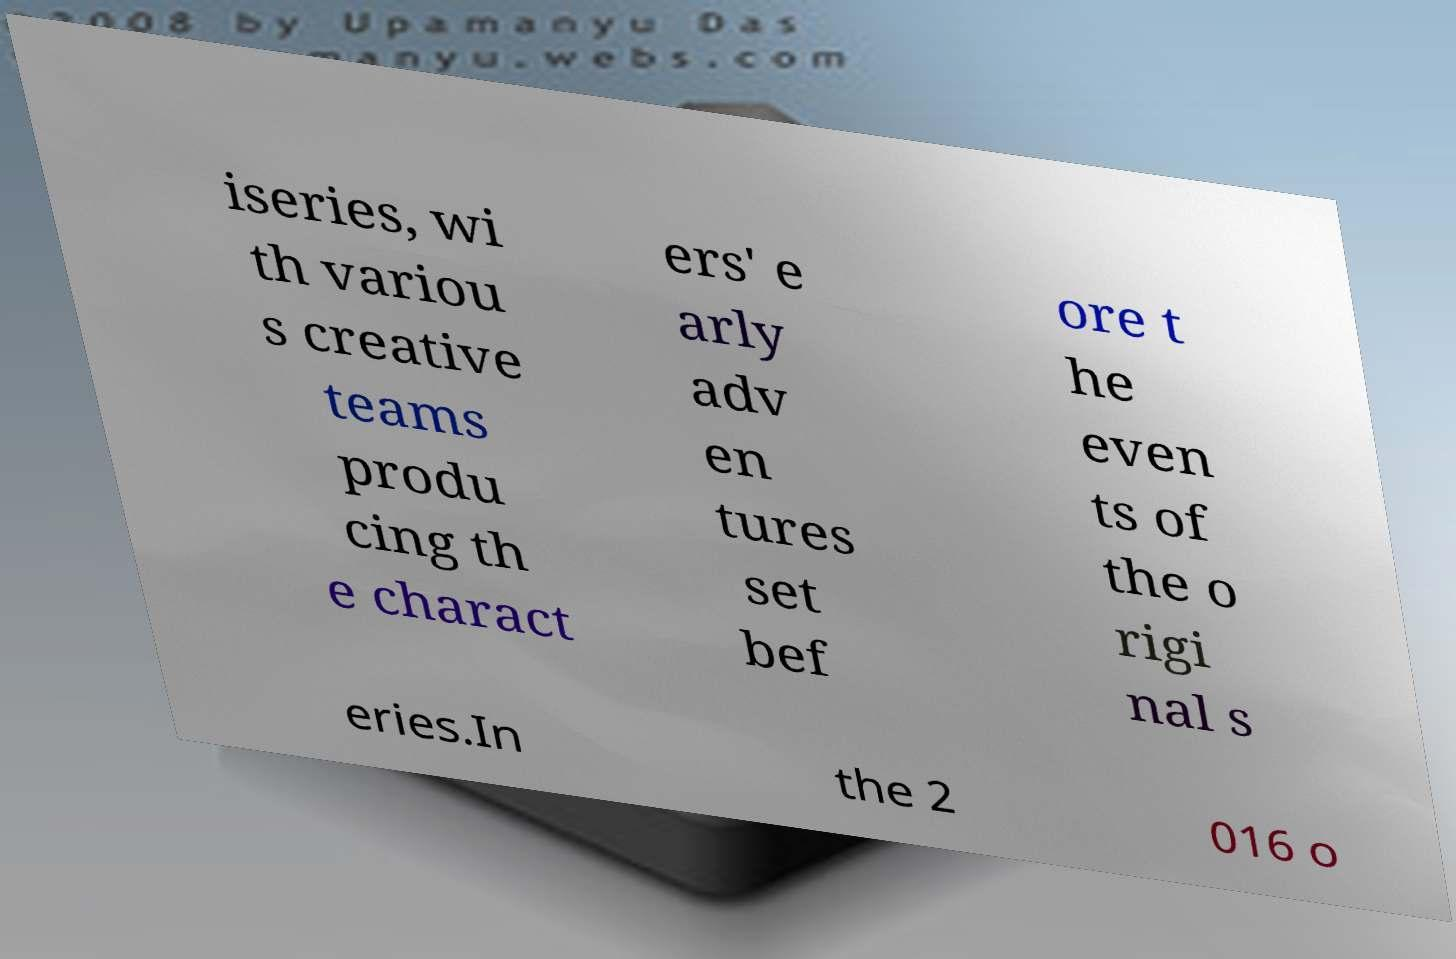What messages or text are displayed in this image? I need them in a readable, typed format. iseries, wi th variou s creative teams produ cing th e charact ers' e arly adv en tures set bef ore t he even ts of the o rigi nal s eries.In the 2 016 o 